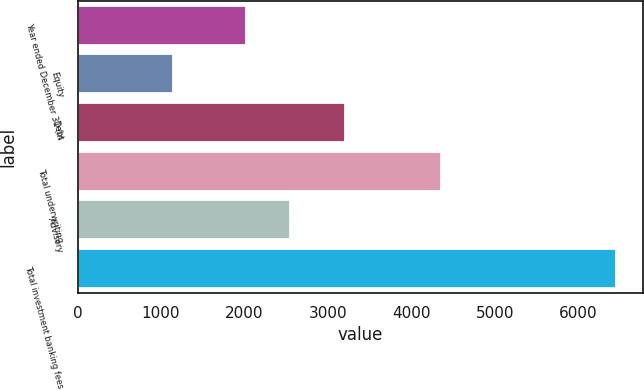<chart> <loc_0><loc_0><loc_500><loc_500><bar_chart><fcel>Year ended December 31 (in<fcel>Equity<fcel>Debt<fcel>Total underwriting<fcel>Advisory<fcel>Total investment banking fees<nl><fcel>2016<fcel>1146<fcel>3207<fcel>4353<fcel>2546.2<fcel>6448<nl></chart> 